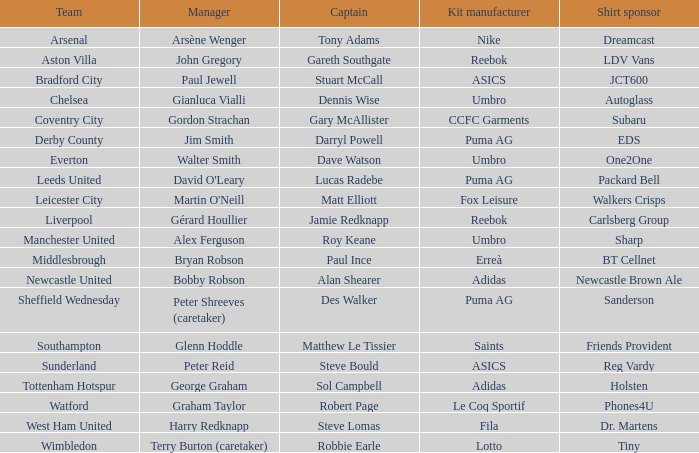Which team has david o'leary as their manager? Leeds United. 